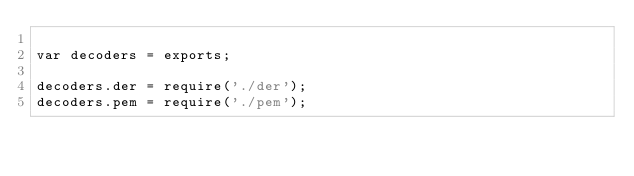<code> <loc_0><loc_0><loc_500><loc_500><_JavaScript_>
var decoders = exports;

decoders.der = require('./der');
decoders.pem = require('./pem');</code> 